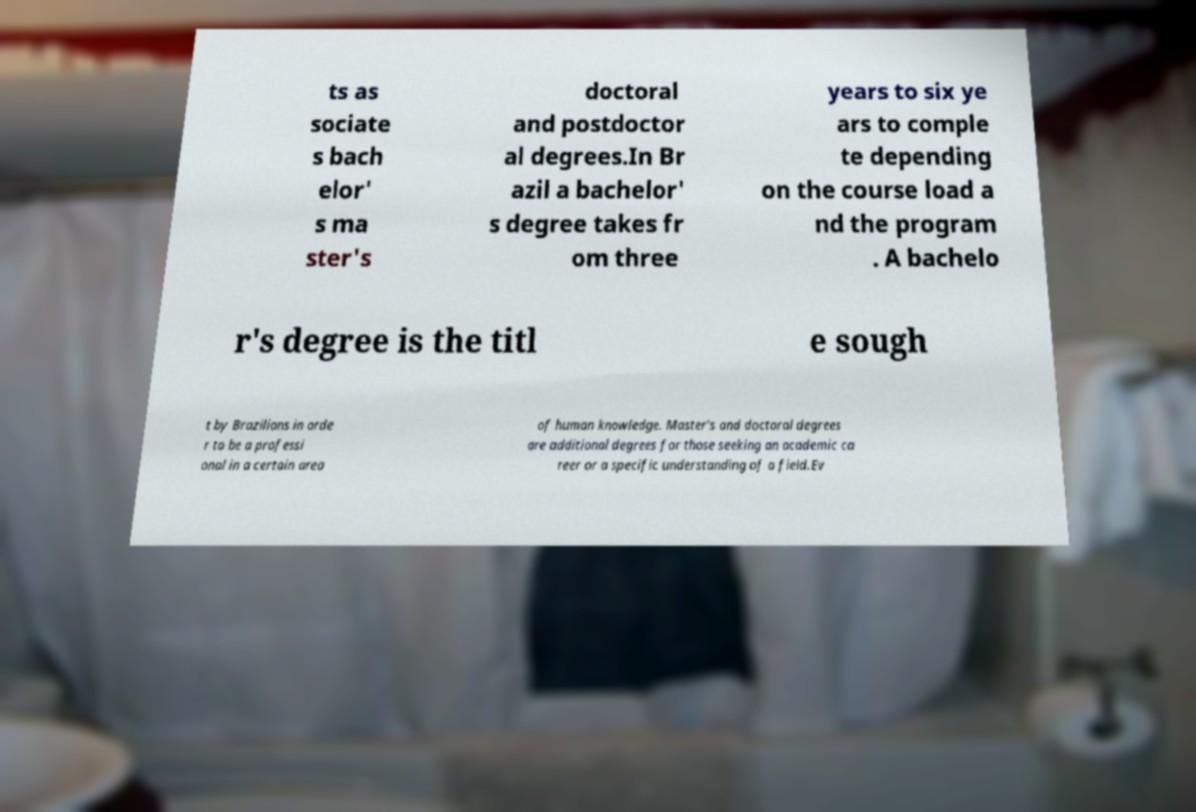Please identify and transcribe the text found in this image. ts as sociate s bach elor' s ma ster's doctoral and postdoctor al degrees.In Br azil a bachelor' s degree takes fr om three years to six ye ars to comple te depending on the course load a nd the program . A bachelo r's degree is the titl e sough t by Brazilians in orde r to be a professi onal in a certain area of human knowledge. Master's and doctoral degrees are additional degrees for those seeking an academic ca reer or a specific understanding of a field.Ev 